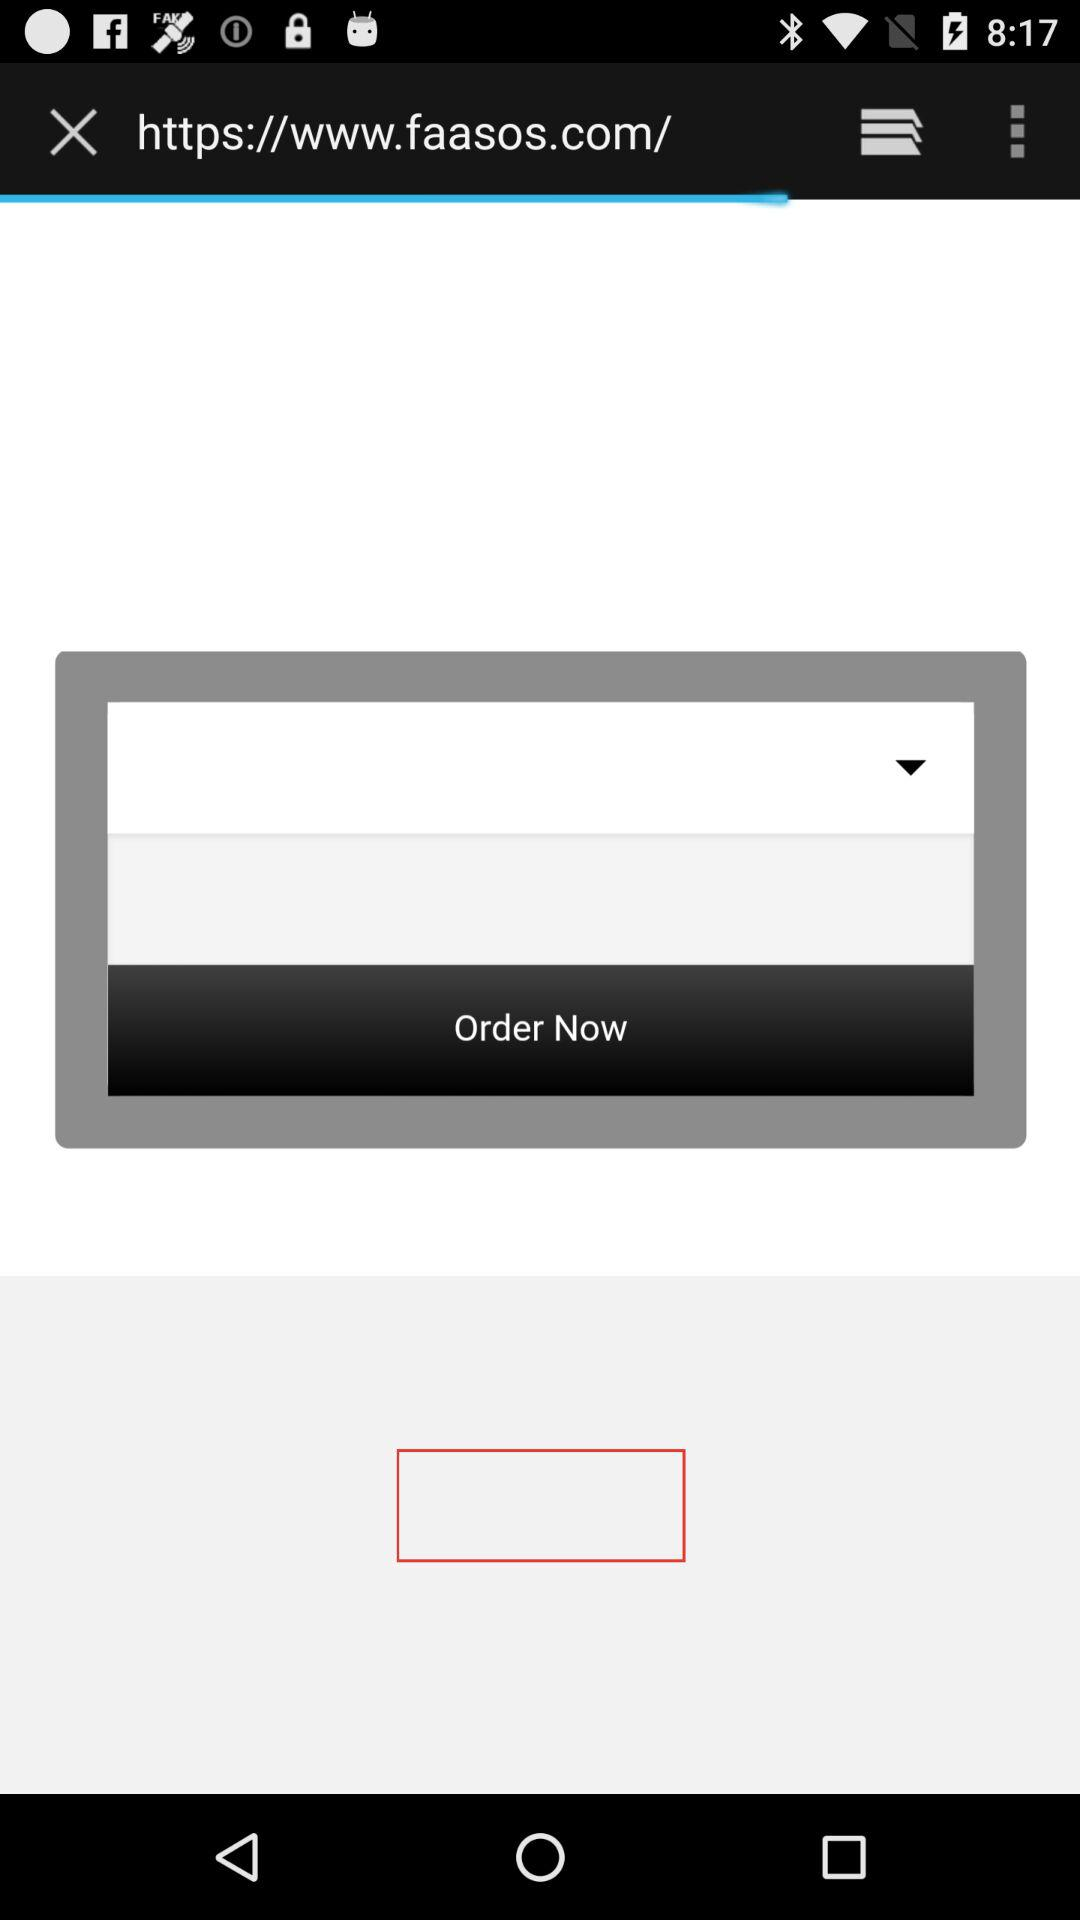What is the name of application?
When the provided information is insufficient, respond with <no answer>. <no answer> 